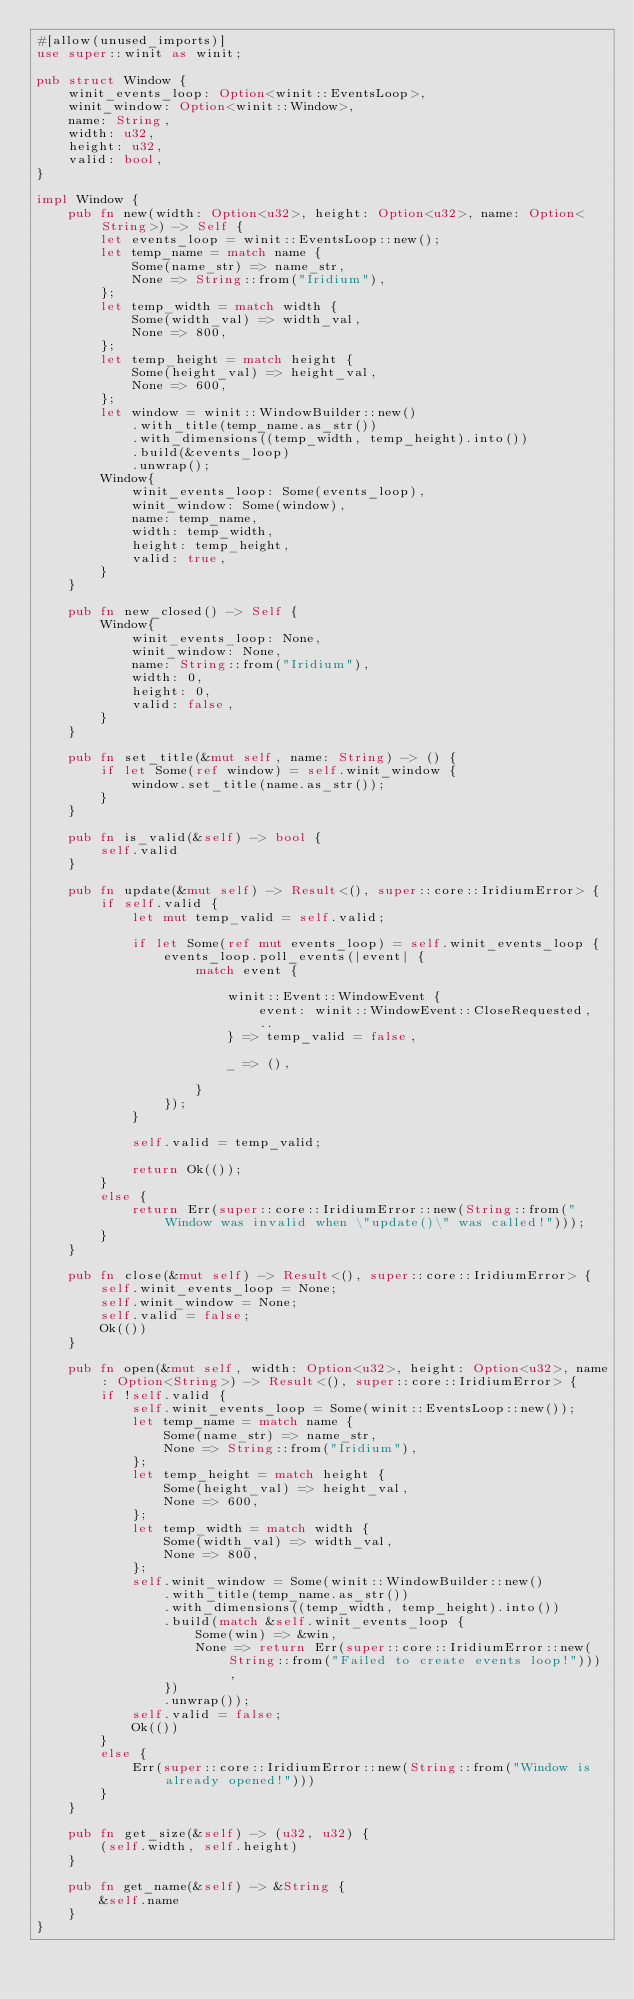<code> <loc_0><loc_0><loc_500><loc_500><_Rust_>#[allow(unused_imports)]
use super::winit as winit;

pub struct Window {
    winit_events_loop: Option<winit::EventsLoop>,
    winit_window: Option<winit::Window>,
    name: String,
    width: u32,
    height: u32,
    valid: bool,
}

impl Window {
    pub fn new(width: Option<u32>, height: Option<u32>, name: Option<String>) -> Self {
        let events_loop = winit::EventsLoop::new();
        let temp_name = match name {
            Some(name_str) => name_str,
            None => String::from("Iridium"),
        };
        let temp_width = match width {
            Some(width_val) => width_val,
            None => 800,
        };
        let temp_height = match height {
            Some(height_val) => height_val,
            None => 600,
        };
        let window = winit::WindowBuilder::new()
            .with_title(temp_name.as_str())
            .with_dimensions((temp_width, temp_height).into())
            .build(&events_loop)
            .unwrap();
        Window{
            winit_events_loop: Some(events_loop),
            winit_window: Some(window),
            name: temp_name,
            width: temp_width,
            height: temp_height,
            valid: true,
        }
    }

    pub fn new_closed() -> Self {
        Window{
            winit_events_loop: None,
            winit_window: None,
            name: String::from("Iridium"),
            width: 0,
            height: 0,
            valid: false,
        }
    }

    pub fn set_title(&mut self, name: String) -> () {
        if let Some(ref window) = self.winit_window {
            window.set_title(name.as_str());
        }
    }

    pub fn is_valid(&self) -> bool {
        self.valid
    }

    pub fn update(&mut self) -> Result<(), super::core::IridiumError> {
        if self.valid {
            let mut temp_valid = self.valid;

            if let Some(ref mut events_loop) = self.winit_events_loop {
                events_loop.poll_events(|event| {
                    match event {

                        winit::Event::WindowEvent {
                            event: winit::WindowEvent::CloseRequested,
                            ..
                        } => temp_valid = false,

                        _ => (),

                    }
                });
            }

            self.valid = temp_valid;

            return Ok(());
        }
        else {
            return Err(super::core::IridiumError::new(String::from("Window was invalid when \"update()\" was called!")));
        }
    }

    pub fn close(&mut self) -> Result<(), super::core::IridiumError> {
        self.winit_events_loop = None;
        self.winit_window = None;
        self.valid = false;
        Ok(())
    }

    pub fn open(&mut self, width: Option<u32>, height: Option<u32>, name: Option<String>) -> Result<(), super::core::IridiumError> {
        if !self.valid {
            self.winit_events_loop = Some(winit::EventsLoop::new());
            let temp_name = match name {
                Some(name_str) => name_str,
                None => String::from("Iridium"),
            };
            let temp_height = match height {
                Some(height_val) => height_val,
                None => 600,
            };
            let temp_width = match width {
                Some(width_val) => width_val,
                None => 800,
            };
            self.winit_window = Some(winit::WindowBuilder::new()
                .with_title(temp_name.as_str())
                .with_dimensions((temp_width, temp_height).into())
                .build(match &self.winit_events_loop {
                    Some(win) => &win,
                    None => return Err(super::core::IridiumError::new(String::from("Failed to create events loop!"))),
                })
                .unwrap());
            self.valid = false;
            Ok(())
        }
        else {
            Err(super::core::IridiumError::new(String::from("Window is already opened!")))
        }
    }

    pub fn get_size(&self) -> (u32, u32) {
        (self.width, self.height)
    }

    pub fn get_name(&self) -> &String {
        &self.name
    }
}</code> 